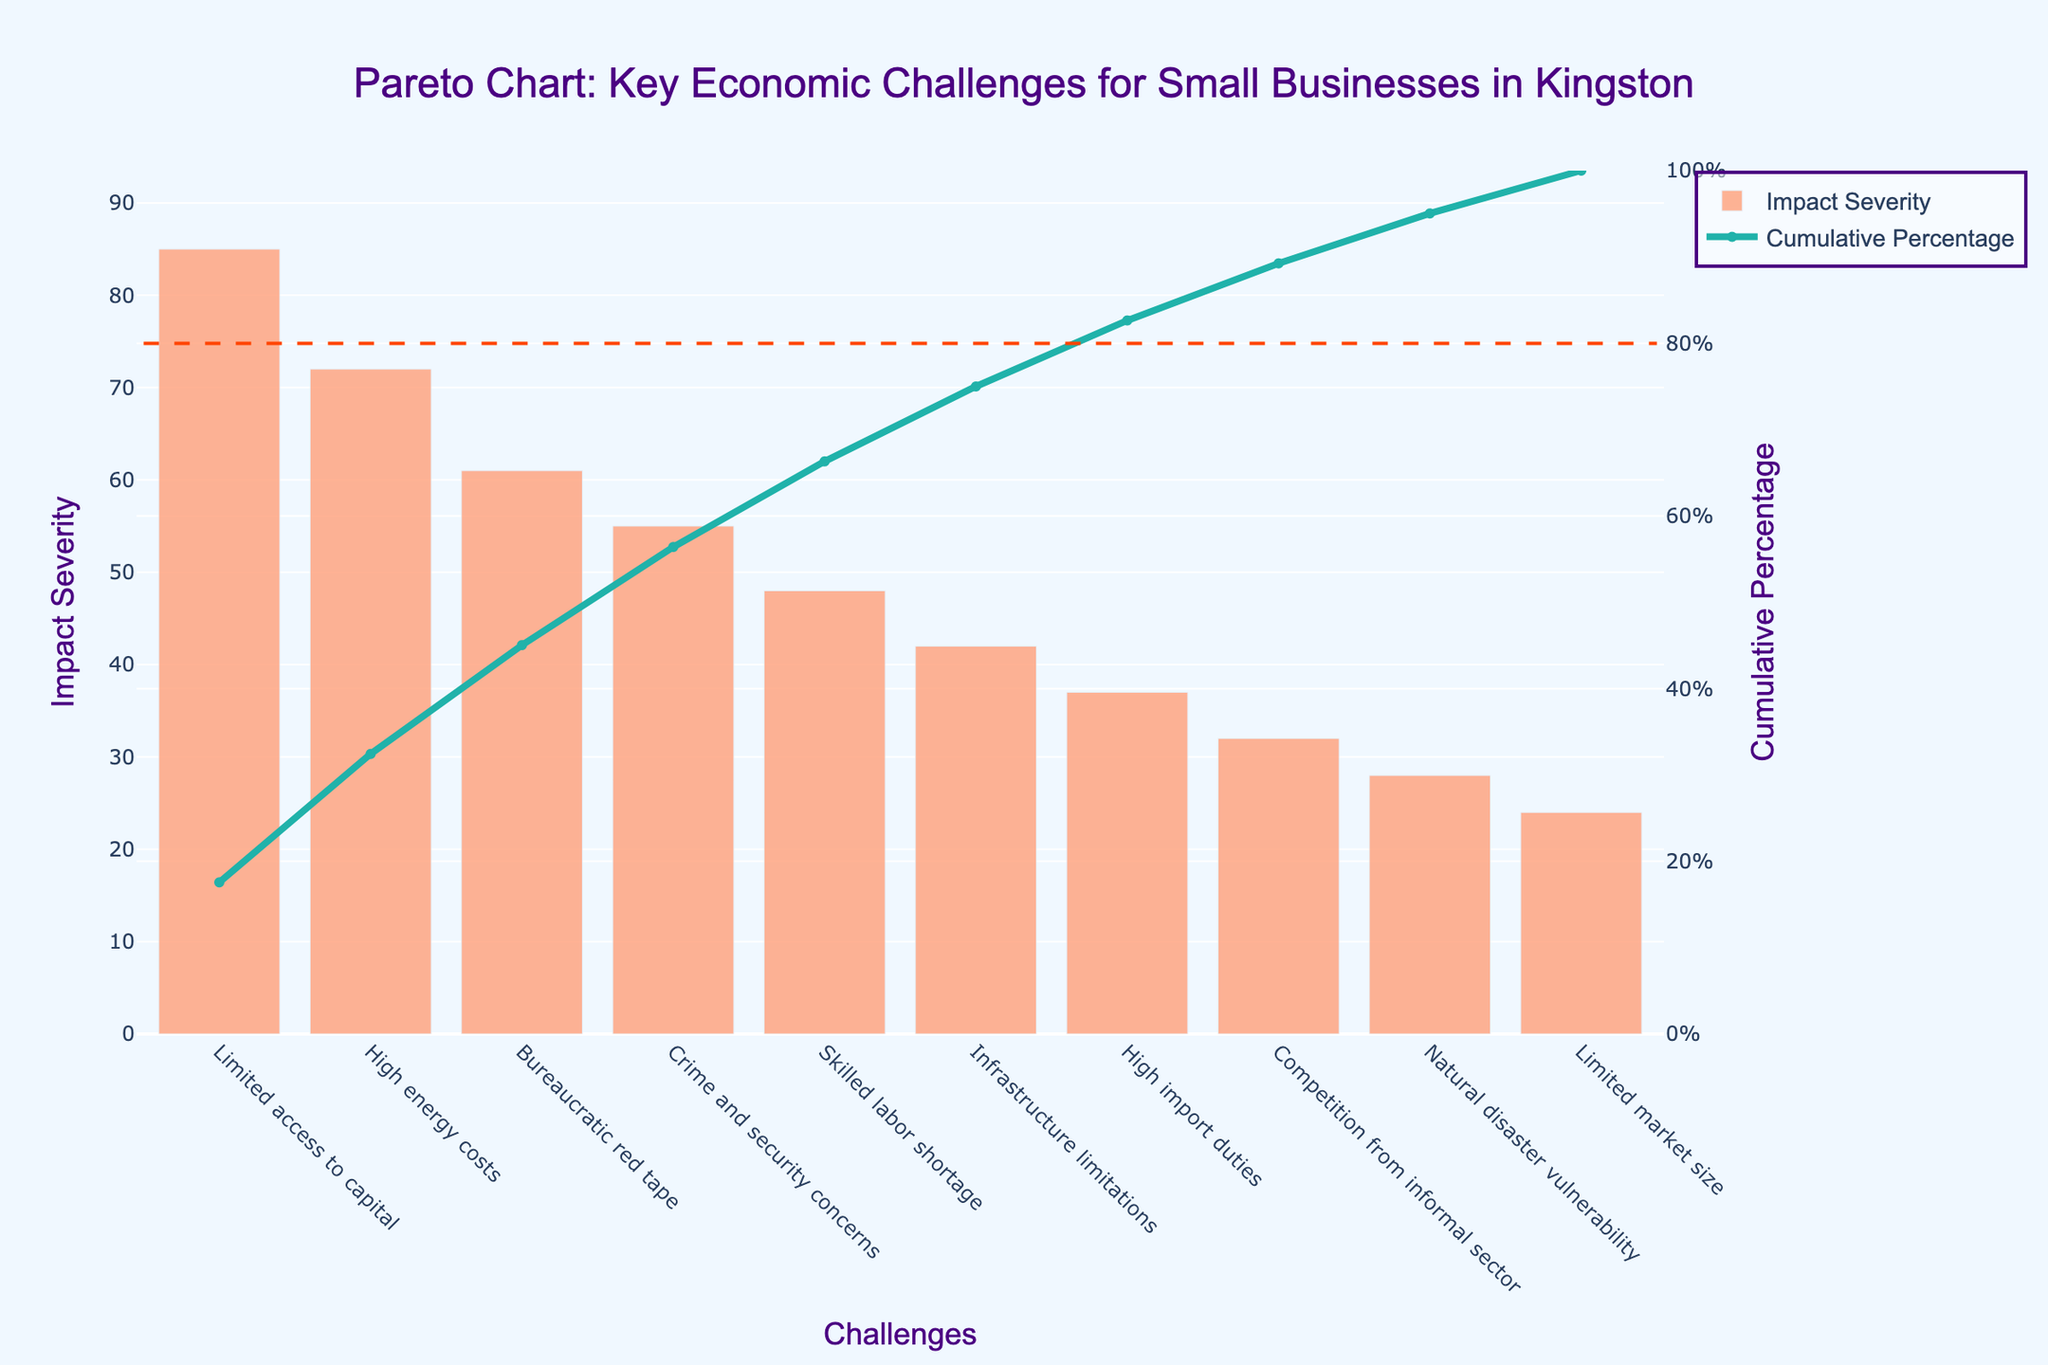What is the title of the chart? The title of the chart is written at the top and describes the overall content of the chart. In this case, it reads "Pareto Chart: Key Economic Challenges for Small Businesses in Kingston".
Answer: Pareto Chart: Key Economic Challenges for Small Businesses in Kingston What are the two axes titles in the chart? The axes titles provide context for the data presented in the chart. The x-axis represents "Challenges" and the primary y-axis represents "Impact Severity", while the secondary y-axis represents "Cumulative Percentage".
Answer: Challenges, Impact Severity, Cumulative Percentage How many economic challenges are listed in the chart? By counting the distinct bars along the x-axis, you can see that there are 10 different economic challenges displayed in the chart.
Answer: 10 Which challenge has the highest impact severity? The challenge with the highest bar represents the one with the highest impact severity. This is "Limited access to capital" at 85.
Answer: Limited access to capital What is the cumulative percentage when considering "Crime and security concerns"? To find this, you refer to the cumulative percentage line corresponding to the "Crime and security concerns" position, which is directly above the bar. The cumulative percentage at this point is approximately 84%.
Answer: 84% What is the total impact severity combining 'High import duties' and 'Competition from informal sector'? Determine the impact severity of 'High import duties' (37) and 'Competition from informal sector' (32), then sum these values (37 + 32).
Answer: 69 Which challenge has a lower impact severity: "Skilled labor shortage" or "Infrastructure limitations"? Compare the heights of the bars for "Skilled labor shortage" (48) and "Infrastructure limitations" (42). The shorter bar has the lower impact severity, which is "Infrastructure limitations".
Answer: Infrastructure limitations What percentage of the impact severity is covered by the four top challenges? First, identify and sum the impact severities of the top four challenges: "Limited access to capital" (85), "High energy costs" (72), "Bureaucratic red tape" (61), and "Crime and security concerns" (55). Calculate their sum (85 + 72 + 61 + 55 = 273), then divide by the total impact severity sum (485) and multiply by 100 to get the percentage: (273/485) * 100 ≈ 56.3%.
Answer: 56.3% What infractions appear at the 80% cumulative percentage line? The horizontal dashed line at 80% intersects the cumulative percentage curve. Identify the challenges at or before this intersection. It includes up to "Skilled labor shortage" as this challenge's cumulative percentage is beyond 80%.
Answer: Skilled labor shortage How does the impact severity of "Natural disaster vulnerability" compare to "High import duties"? Look at the heights of the respective bars. "Natural disaster vulnerability" has an impact severity of 28, while "High import duties" have an impact severity of 37. The former is less impactful.
Answer: Natural disaster vulnerability is less impactful 